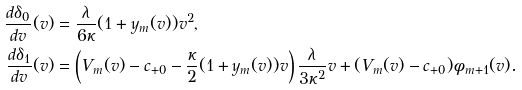<formula> <loc_0><loc_0><loc_500><loc_500>\frac { d \delta _ { 0 } } { d v } ( v ) & = \frac { \lambda } { 6 \kappa } ( 1 + y _ { m } ( v ) ) v ^ { 2 } , \\ \frac { d \delta _ { 1 } } { d v } ( v ) & = \left ( V _ { m } ( v ) - c _ { + 0 } - \frac { \kappa } { 2 } ( 1 + y _ { m } ( v ) ) v \right ) \frac { \lambda } { 3 \kappa ^ { 2 } } v + ( V _ { m } ( v ) - c _ { + 0 } ) \phi _ { m + 1 } ( v ) .</formula> 